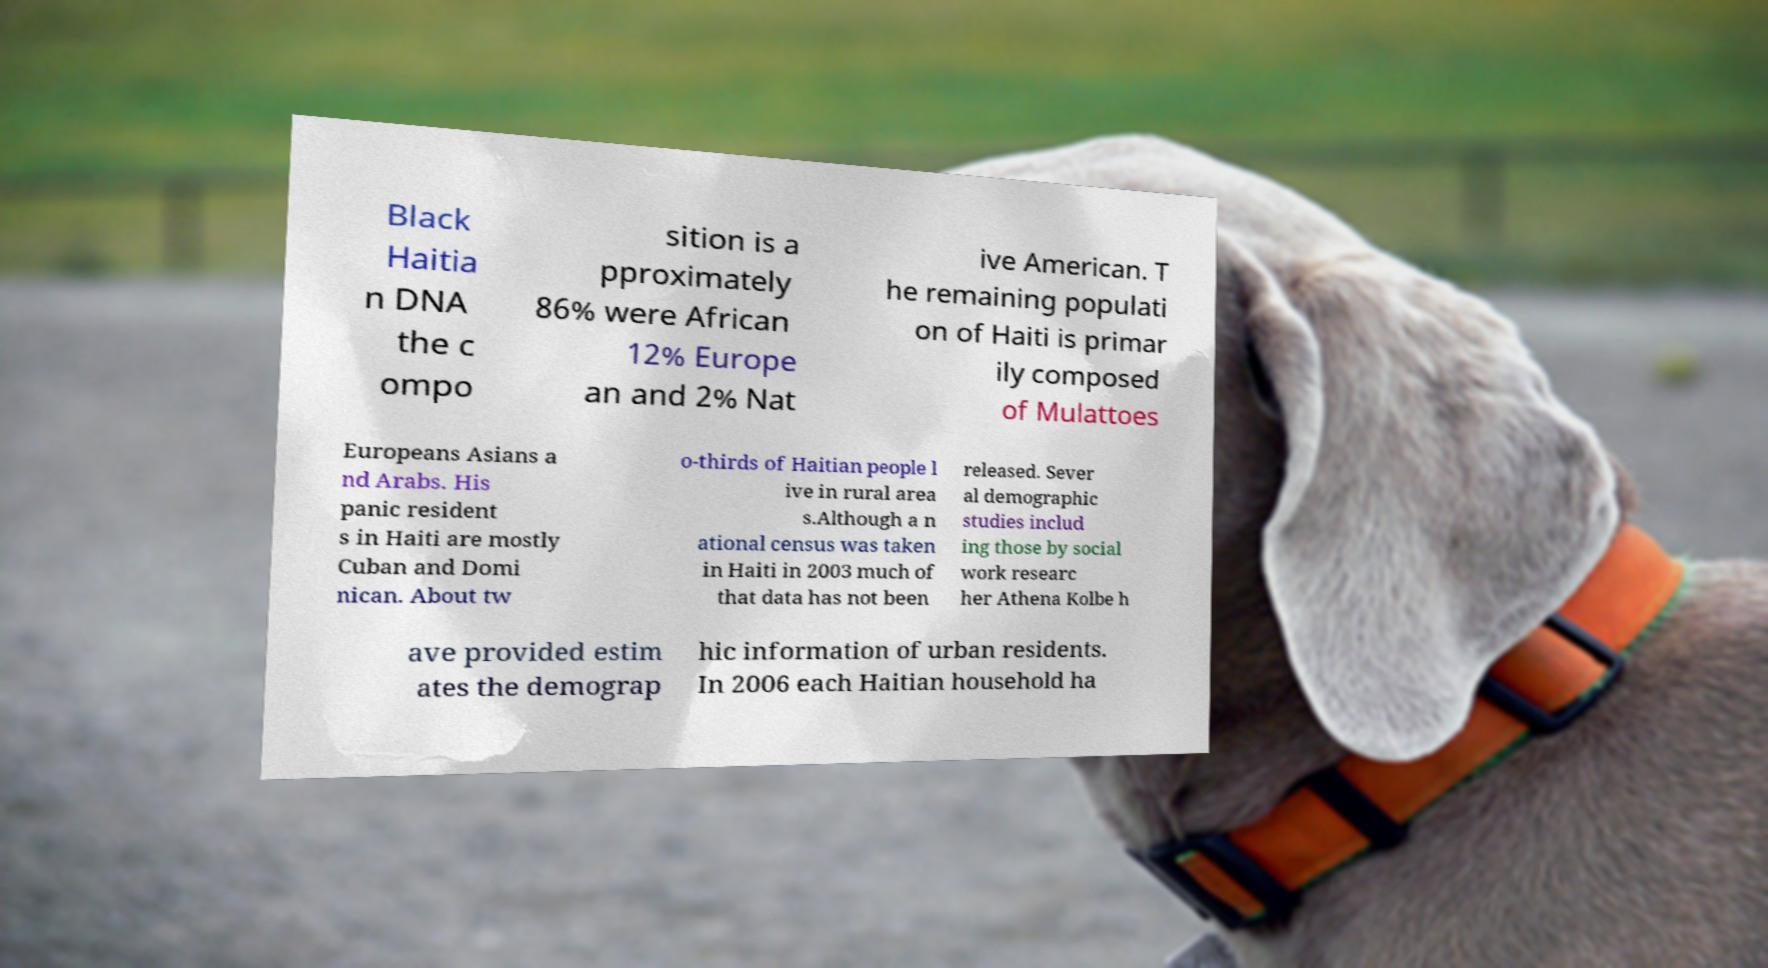Please read and relay the text visible in this image. What does it say? Black Haitia n DNA the c ompo sition is a pproximately 86% were African 12% Europe an and 2% Nat ive American. T he remaining populati on of Haiti is primar ily composed of Mulattoes Europeans Asians a nd Arabs. His panic resident s in Haiti are mostly Cuban and Domi nican. About tw o-thirds of Haitian people l ive in rural area s.Although a n ational census was taken in Haiti in 2003 much of that data has not been released. Sever al demographic studies includ ing those by social work researc her Athena Kolbe h ave provided estim ates the demograp hic information of urban residents. In 2006 each Haitian household ha 